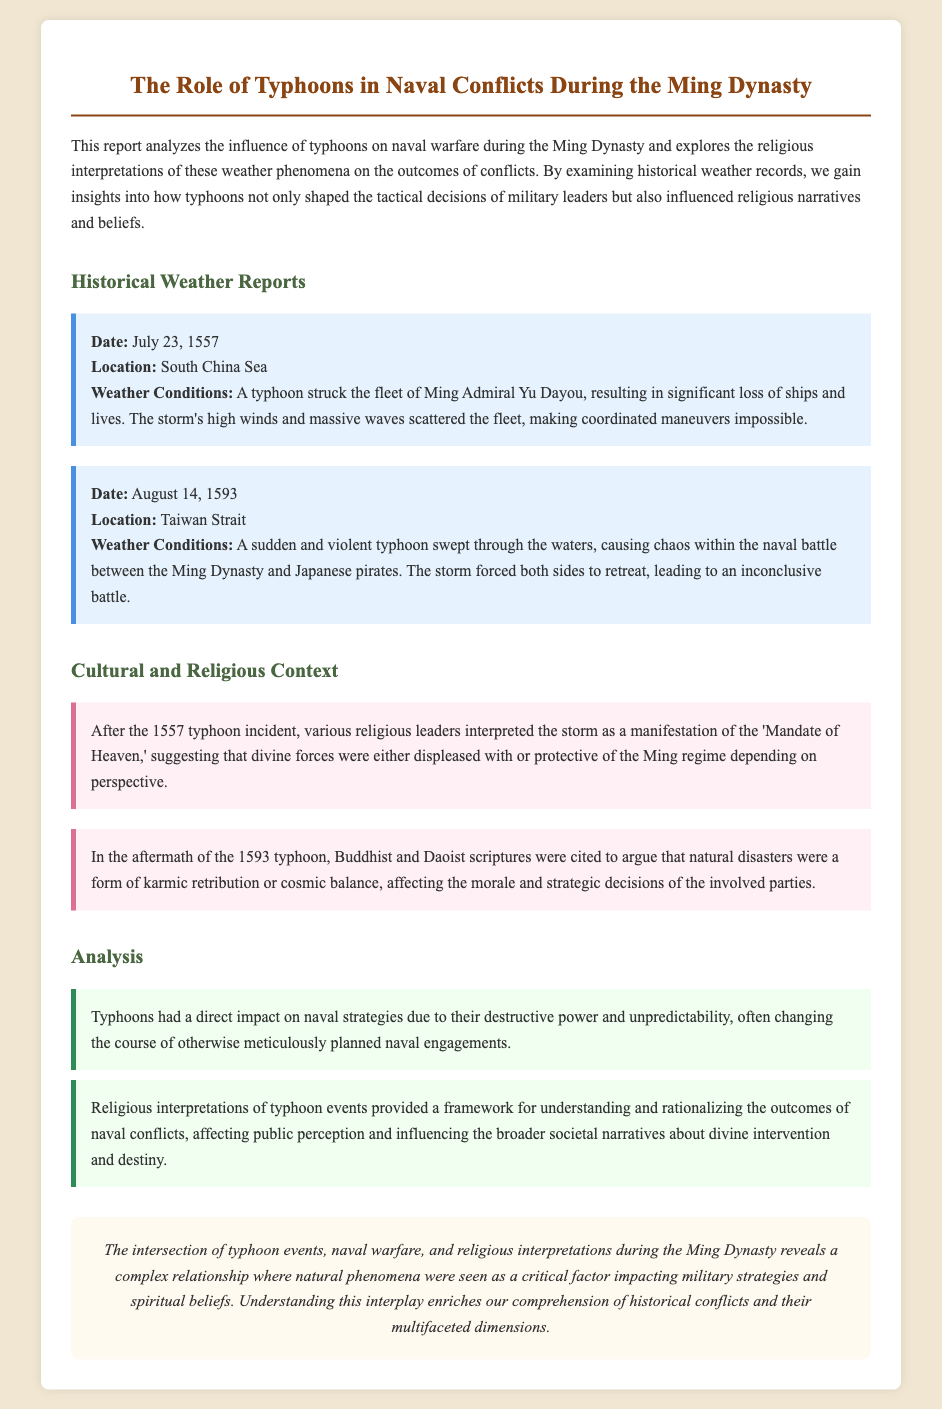What date did the typhoon strike Admiral Yu Dayou's fleet? The document states that the typhoon struck the fleet of Ming Admiral Yu Dayou on July 23, 1557.
Answer: July 23, 1557 What interpretation did religious leaders give after the 1557 typhoon? The document mentions that various religious leaders interpreted the storm as a manifestation of the 'Mandate of Heaven.'
Answer: Mandate of Heaven How many naval conflicts were discussed in the report? The document discusses two specific naval conflicts affected by typhoons: one in 1557 and another in 1593.
Answer: Two Where did the typhoon occur on August 14, 1593? The report specifies that the violent typhoon occurred in the Taiwan Strait.
Answer: Taiwan Strait What framework did religious interpretations provide regarding natural disasters? According to the document, religious interpretations provided a framework for understanding and rationalizing the outcomes of naval conflicts.
Answer: Understanding and rationalizing What was the result of the naval battle on August 14, 1593? The document states that the storm led to chaos and made both sides retreat, resulting in an inconclusive battle.
Answer: Inconclusive battle What major impact did typhoons have on naval strategies? The analysis point in the document indicates that typhoons had a direct impact on naval strategies due to their destructive power and unpredictability.
Answer: Destructive power and unpredictability 